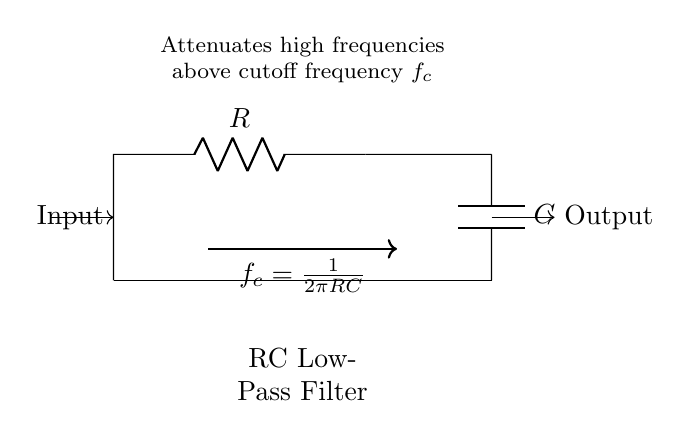What type of filter is this circuit? The circuit is described as an "RC Low-Pass Filter," which is indicated directly in the diagram and also explained in the text provided within the drawing.
Answer: RC Low-Pass Filter What are the two components used in this circuit? The circuit contains a resistor labeled as "R" and a capacitor labeled as "C," which are essential for its operation as a low-pass filter.
Answer: R, C What does this filter do to high frequencies? The text in the circuit diagram states that the filter "attenuates high frequencies above cutoff frequency," indicating its function to reduce unwanted frequencies in audio signals.
Answer: Attenuates What is the formula for the cutoff frequency? The diagram provides the formula for cutoff frequency as "f_c = 1/(2πRC)," showcasing how the frequency is mathematically determined based on the resistance and capacitance values.
Answer: 1/(2πRC) What happens to signals below the cutoff frequency? While the diagram does not explicitly state this, it is understood that signals that are below the cutoff frequency are allowed to pass through with little to no attenuation, based on the function of a low-pass filter.
Answer: Pass through What role does the capacitor play in the circuit? The capacitor in this low-pass filter is responsible for blocking high-frequency signals while allowing low-frequency signals to pass, which is critical for noise reduction in audio applications.
Answer: Blocks high frequencies What is the characteristic of the output signal compared to the input? The output signal will be lower in amplitude compared to the input signal for frequencies above the cutoff, as indicated by the function of a low-pass filter to reduce high-frequency content.
Answer: Lower amplitude 